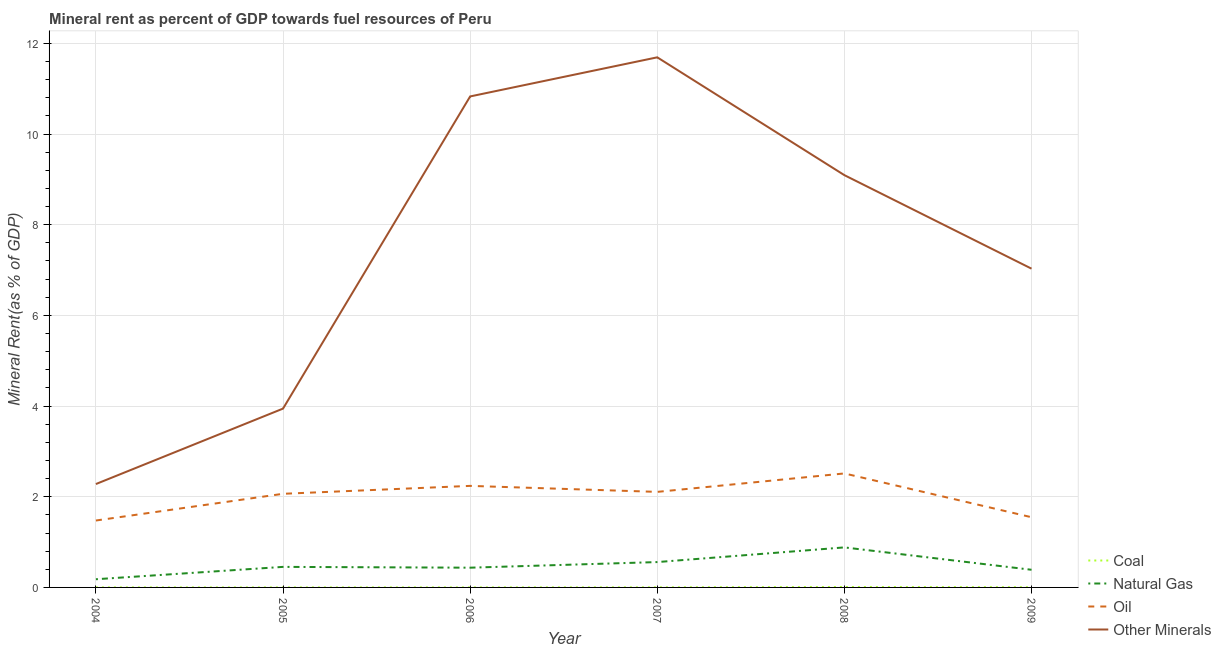Is the number of lines equal to the number of legend labels?
Offer a very short reply. Yes. What is the coal rent in 2007?
Make the answer very short. 0. Across all years, what is the maximum coal rent?
Your answer should be very brief. 0.01. Across all years, what is the minimum coal rent?
Offer a terse response. 0. What is the total  rent of other minerals in the graph?
Keep it short and to the point. 44.87. What is the difference between the natural gas rent in 2006 and that in 2007?
Your answer should be very brief. -0.12. What is the difference between the natural gas rent in 2004 and the coal rent in 2005?
Your answer should be very brief. 0.18. What is the average coal rent per year?
Your answer should be very brief. 0. In the year 2009, what is the difference between the natural gas rent and  rent of other minerals?
Provide a short and direct response. -6.64. What is the ratio of the  rent of other minerals in 2004 to that in 2006?
Keep it short and to the point. 0.21. Is the natural gas rent in 2005 less than that in 2007?
Ensure brevity in your answer.  Yes. Is the difference between the  rent of other minerals in 2007 and 2009 greater than the difference between the coal rent in 2007 and 2009?
Provide a short and direct response. Yes. What is the difference between the highest and the second highest natural gas rent?
Offer a terse response. 0.32. What is the difference between the highest and the lowest coal rent?
Your response must be concise. 0.01. Is it the case that in every year, the sum of the coal rent and natural gas rent is greater than the oil rent?
Your answer should be very brief. No. Does the  rent of other minerals monotonically increase over the years?
Offer a very short reply. No. Is the natural gas rent strictly greater than the coal rent over the years?
Offer a terse response. Yes. Is the natural gas rent strictly less than the coal rent over the years?
Provide a short and direct response. No. How many lines are there?
Ensure brevity in your answer.  4. Does the graph contain any zero values?
Your answer should be very brief. No. Does the graph contain grids?
Ensure brevity in your answer.  Yes. How many legend labels are there?
Provide a short and direct response. 4. How are the legend labels stacked?
Keep it short and to the point. Vertical. What is the title of the graph?
Offer a terse response. Mineral rent as percent of GDP towards fuel resources of Peru. What is the label or title of the Y-axis?
Offer a very short reply. Mineral Rent(as % of GDP). What is the Mineral Rent(as % of GDP) of Coal in 2004?
Ensure brevity in your answer.  0. What is the Mineral Rent(as % of GDP) of Natural Gas in 2004?
Offer a very short reply. 0.18. What is the Mineral Rent(as % of GDP) of Oil in 2004?
Keep it short and to the point. 1.48. What is the Mineral Rent(as % of GDP) in Other Minerals in 2004?
Give a very brief answer. 2.28. What is the Mineral Rent(as % of GDP) in Coal in 2005?
Your answer should be very brief. 0. What is the Mineral Rent(as % of GDP) of Natural Gas in 2005?
Make the answer very short. 0.45. What is the Mineral Rent(as % of GDP) in Oil in 2005?
Your answer should be very brief. 2.07. What is the Mineral Rent(as % of GDP) of Other Minerals in 2005?
Ensure brevity in your answer.  3.94. What is the Mineral Rent(as % of GDP) in Coal in 2006?
Offer a terse response. 0. What is the Mineral Rent(as % of GDP) of Natural Gas in 2006?
Your answer should be compact. 0.44. What is the Mineral Rent(as % of GDP) of Oil in 2006?
Your answer should be very brief. 2.24. What is the Mineral Rent(as % of GDP) in Other Minerals in 2006?
Your answer should be very brief. 10.83. What is the Mineral Rent(as % of GDP) of Coal in 2007?
Keep it short and to the point. 0. What is the Mineral Rent(as % of GDP) of Natural Gas in 2007?
Your answer should be compact. 0.56. What is the Mineral Rent(as % of GDP) in Oil in 2007?
Your response must be concise. 2.11. What is the Mineral Rent(as % of GDP) in Other Minerals in 2007?
Your answer should be very brief. 11.69. What is the Mineral Rent(as % of GDP) in Coal in 2008?
Give a very brief answer. 0.01. What is the Mineral Rent(as % of GDP) of Natural Gas in 2008?
Your answer should be compact. 0.88. What is the Mineral Rent(as % of GDP) of Oil in 2008?
Keep it short and to the point. 2.51. What is the Mineral Rent(as % of GDP) in Other Minerals in 2008?
Ensure brevity in your answer.  9.09. What is the Mineral Rent(as % of GDP) of Coal in 2009?
Provide a short and direct response. 0. What is the Mineral Rent(as % of GDP) in Natural Gas in 2009?
Your answer should be compact. 0.39. What is the Mineral Rent(as % of GDP) of Oil in 2009?
Offer a terse response. 1.55. What is the Mineral Rent(as % of GDP) of Other Minerals in 2009?
Keep it short and to the point. 7.03. Across all years, what is the maximum Mineral Rent(as % of GDP) in Coal?
Your answer should be compact. 0.01. Across all years, what is the maximum Mineral Rent(as % of GDP) of Natural Gas?
Offer a very short reply. 0.88. Across all years, what is the maximum Mineral Rent(as % of GDP) in Oil?
Provide a succinct answer. 2.51. Across all years, what is the maximum Mineral Rent(as % of GDP) of Other Minerals?
Offer a terse response. 11.69. Across all years, what is the minimum Mineral Rent(as % of GDP) in Coal?
Keep it short and to the point. 0. Across all years, what is the minimum Mineral Rent(as % of GDP) in Natural Gas?
Ensure brevity in your answer.  0.18. Across all years, what is the minimum Mineral Rent(as % of GDP) in Oil?
Offer a terse response. 1.48. Across all years, what is the minimum Mineral Rent(as % of GDP) in Other Minerals?
Make the answer very short. 2.28. What is the total Mineral Rent(as % of GDP) of Coal in the graph?
Ensure brevity in your answer.  0.02. What is the total Mineral Rent(as % of GDP) of Natural Gas in the graph?
Offer a very short reply. 2.9. What is the total Mineral Rent(as % of GDP) in Oil in the graph?
Offer a very short reply. 11.95. What is the total Mineral Rent(as % of GDP) in Other Minerals in the graph?
Offer a terse response. 44.87. What is the difference between the Mineral Rent(as % of GDP) in Coal in 2004 and that in 2005?
Offer a terse response. 0. What is the difference between the Mineral Rent(as % of GDP) of Natural Gas in 2004 and that in 2005?
Ensure brevity in your answer.  -0.27. What is the difference between the Mineral Rent(as % of GDP) of Oil in 2004 and that in 2005?
Your answer should be very brief. -0.59. What is the difference between the Mineral Rent(as % of GDP) in Other Minerals in 2004 and that in 2005?
Ensure brevity in your answer.  -1.66. What is the difference between the Mineral Rent(as % of GDP) of Coal in 2004 and that in 2006?
Your response must be concise. -0. What is the difference between the Mineral Rent(as % of GDP) in Natural Gas in 2004 and that in 2006?
Keep it short and to the point. -0.25. What is the difference between the Mineral Rent(as % of GDP) of Oil in 2004 and that in 2006?
Ensure brevity in your answer.  -0.76. What is the difference between the Mineral Rent(as % of GDP) in Other Minerals in 2004 and that in 2006?
Your answer should be very brief. -8.55. What is the difference between the Mineral Rent(as % of GDP) of Coal in 2004 and that in 2007?
Offer a very short reply. -0. What is the difference between the Mineral Rent(as % of GDP) in Natural Gas in 2004 and that in 2007?
Your answer should be compact. -0.38. What is the difference between the Mineral Rent(as % of GDP) of Oil in 2004 and that in 2007?
Offer a very short reply. -0.63. What is the difference between the Mineral Rent(as % of GDP) of Other Minerals in 2004 and that in 2007?
Provide a short and direct response. -9.41. What is the difference between the Mineral Rent(as % of GDP) of Coal in 2004 and that in 2008?
Ensure brevity in your answer.  -0.01. What is the difference between the Mineral Rent(as % of GDP) in Natural Gas in 2004 and that in 2008?
Ensure brevity in your answer.  -0.7. What is the difference between the Mineral Rent(as % of GDP) of Oil in 2004 and that in 2008?
Make the answer very short. -1.04. What is the difference between the Mineral Rent(as % of GDP) in Other Minerals in 2004 and that in 2008?
Your answer should be compact. -6.81. What is the difference between the Mineral Rent(as % of GDP) in Coal in 2004 and that in 2009?
Keep it short and to the point. -0. What is the difference between the Mineral Rent(as % of GDP) of Natural Gas in 2004 and that in 2009?
Provide a succinct answer. -0.21. What is the difference between the Mineral Rent(as % of GDP) of Oil in 2004 and that in 2009?
Give a very brief answer. -0.07. What is the difference between the Mineral Rent(as % of GDP) in Other Minerals in 2004 and that in 2009?
Make the answer very short. -4.75. What is the difference between the Mineral Rent(as % of GDP) in Coal in 2005 and that in 2006?
Provide a short and direct response. -0. What is the difference between the Mineral Rent(as % of GDP) in Natural Gas in 2005 and that in 2006?
Your answer should be compact. 0.02. What is the difference between the Mineral Rent(as % of GDP) of Oil in 2005 and that in 2006?
Your answer should be very brief. -0.17. What is the difference between the Mineral Rent(as % of GDP) in Other Minerals in 2005 and that in 2006?
Offer a terse response. -6.89. What is the difference between the Mineral Rent(as % of GDP) of Coal in 2005 and that in 2007?
Keep it short and to the point. -0. What is the difference between the Mineral Rent(as % of GDP) of Natural Gas in 2005 and that in 2007?
Ensure brevity in your answer.  -0.11. What is the difference between the Mineral Rent(as % of GDP) in Oil in 2005 and that in 2007?
Give a very brief answer. -0.04. What is the difference between the Mineral Rent(as % of GDP) in Other Minerals in 2005 and that in 2007?
Offer a terse response. -7.75. What is the difference between the Mineral Rent(as % of GDP) in Coal in 2005 and that in 2008?
Your response must be concise. -0.01. What is the difference between the Mineral Rent(as % of GDP) in Natural Gas in 2005 and that in 2008?
Provide a succinct answer. -0.43. What is the difference between the Mineral Rent(as % of GDP) of Oil in 2005 and that in 2008?
Give a very brief answer. -0.45. What is the difference between the Mineral Rent(as % of GDP) in Other Minerals in 2005 and that in 2008?
Give a very brief answer. -5.15. What is the difference between the Mineral Rent(as % of GDP) in Coal in 2005 and that in 2009?
Keep it short and to the point. -0. What is the difference between the Mineral Rent(as % of GDP) in Natural Gas in 2005 and that in 2009?
Your response must be concise. 0.06. What is the difference between the Mineral Rent(as % of GDP) in Oil in 2005 and that in 2009?
Offer a very short reply. 0.52. What is the difference between the Mineral Rent(as % of GDP) of Other Minerals in 2005 and that in 2009?
Provide a succinct answer. -3.09. What is the difference between the Mineral Rent(as % of GDP) in Coal in 2006 and that in 2007?
Your response must be concise. -0. What is the difference between the Mineral Rent(as % of GDP) of Natural Gas in 2006 and that in 2007?
Ensure brevity in your answer.  -0.12. What is the difference between the Mineral Rent(as % of GDP) in Oil in 2006 and that in 2007?
Make the answer very short. 0.13. What is the difference between the Mineral Rent(as % of GDP) in Other Minerals in 2006 and that in 2007?
Your answer should be compact. -0.86. What is the difference between the Mineral Rent(as % of GDP) in Coal in 2006 and that in 2008?
Your response must be concise. -0.01. What is the difference between the Mineral Rent(as % of GDP) of Natural Gas in 2006 and that in 2008?
Make the answer very short. -0.45. What is the difference between the Mineral Rent(as % of GDP) in Oil in 2006 and that in 2008?
Keep it short and to the point. -0.27. What is the difference between the Mineral Rent(as % of GDP) in Other Minerals in 2006 and that in 2008?
Offer a very short reply. 1.74. What is the difference between the Mineral Rent(as % of GDP) of Coal in 2006 and that in 2009?
Your answer should be very brief. -0. What is the difference between the Mineral Rent(as % of GDP) of Natural Gas in 2006 and that in 2009?
Give a very brief answer. 0.05. What is the difference between the Mineral Rent(as % of GDP) of Oil in 2006 and that in 2009?
Your answer should be very brief. 0.69. What is the difference between the Mineral Rent(as % of GDP) in Other Minerals in 2006 and that in 2009?
Offer a very short reply. 3.8. What is the difference between the Mineral Rent(as % of GDP) in Coal in 2007 and that in 2008?
Make the answer very short. -0.01. What is the difference between the Mineral Rent(as % of GDP) of Natural Gas in 2007 and that in 2008?
Provide a short and direct response. -0.32. What is the difference between the Mineral Rent(as % of GDP) in Oil in 2007 and that in 2008?
Keep it short and to the point. -0.41. What is the difference between the Mineral Rent(as % of GDP) of Other Minerals in 2007 and that in 2008?
Provide a short and direct response. 2.6. What is the difference between the Mineral Rent(as % of GDP) of Coal in 2007 and that in 2009?
Your answer should be very brief. -0. What is the difference between the Mineral Rent(as % of GDP) of Natural Gas in 2007 and that in 2009?
Provide a short and direct response. 0.17. What is the difference between the Mineral Rent(as % of GDP) in Oil in 2007 and that in 2009?
Give a very brief answer. 0.56. What is the difference between the Mineral Rent(as % of GDP) of Other Minerals in 2007 and that in 2009?
Provide a short and direct response. 4.66. What is the difference between the Mineral Rent(as % of GDP) in Coal in 2008 and that in 2009?
Provide a short and direct response. 0. What is the difference between the Mineral Rent(as % of GDP) of Natural Gas in 2008 and that in 2009?
Your answer should be compact. 0.49. What is the difference between the Mineral Rent(as % of GDP) of Oil in 2008 and that in 2009?
Offer a very short reply. 0.97. What is the difference between the Mineral Rent(as % of GDP) in Other Minerals in 2008 and that in 2009?
Provide a short and direct response. 2.06. What is the difference between the Mineral Rent(as % of GDP) in Coal in 2004 and the Mineral Rent(as % of GDP) in Natural Gas in 2005?
Offer a very short reply. -0.45. What is the difference between the Mineral Rent(as % of GDP) of Coal in 2004 and the Mineral Rent(as % of GDP) of Oil in 2005?
Keep it short and to the point. -2.06. What is the difference between the Mineral Rent(as % of GDP) in Coal in 2004 and the Mineral Rent(as % of GDP) in Other Minerals in 2005?
Keep it short and to the point. -3.94. What is the difference between the Mineral Rent(as % of GDP) of Natural Gas in 2004 and the Mineral Rent(as % of GDP) of Oil in 2005?
Offer a terse response. -1.88. What is the difference between the Mineral Rent(as % of GDP) in Natural Gas in 2004 and the Mineral Rent(as % of GDP) in Other Minerals in 2005?
Your response must be concise. -3.76. What is the difference between the Mineral Rent(as % of GDP) of Oil in 2004 and the Mineral Rent(as % of GDP) of Other Minerals in 2005?
Your response must be concise. -2.47. What is the difference between the Mineral Rent(as % of GDP) of Coal in 2004 and the Mineral Rent(as % of GDP) of Natural Gas in 2006?
Keep it short and to the point. -0.44. What is the difference between the Mineral Rent(as % of GDP) in Coal in 2004 and the Mineral Rent(as % of GDP) in Oil in 2006?
Ensure brevity in your answer.  -2.24. What is the difference between the Mineral Rent(as % of GDP) in Coal in 2004 and the Mineral Rent(as % of GDP) in Other Minerals in 2006?
Your response must be concise. -10.83. What is the difference between the Mineral Rent(as % of GDP) in Natural Gas in 2004 and the Mineral Rent(as % of GDP) in Oil in 2006?
Your response must be concise. -2.06. What is the difference between the Mineral Rent(as % of GDP) in Natural Gas in 2004 and the Mineral Rent(as % of GDP) in Other Minerals in 2006?
Offer a terse response. -10.65. What is the difference between the Mineral Rent(as % of GDP) in Oil in 2004 and the Mineral Rent(as % of GDP) in Other Minerals in 2006?
Your answer should be very brief. -9.35. What is the difference between the Mineral Rent(as % of GDP) in Coal in 2004 and the Mineral Rent(as % of GDP) in Natural Gas in 2007?
Make the answer very short. -0.56. What is the difference between the Mineral Rent(as % of GDP) of Coal in 2004 and the Mineral Rent(as % of GDP) of Oil in 2007?
Offer a terse response. -2.11. What is the difference between the Mineral Rent(as % of GDP) in Coal in 2004 and the Mineral Rent(as % of GDP) in Other Minerals in 2007?
Give a very brief answer. -11.69. What is the difference between the Mineral Rent(as % of GDP) of Natural Gas in 2004 and the Mineral Rent(as % of GDP) of Oil in 2007?
Your answer should be compact. -1.93. What is the difference between the Mineral Rent(as % of GDP) in Natural Gas in 2004 and the Mineral Rent(as % of GDP) in Other Minerals in 2007?
Your answer should be very brief. -11.51. What is the difference between the Mineral Rent(as % of GDP) of Oil in 2004 and the Mineral Rent(as % of GDP) of Other Minerals in 2007?
Provide a succinct answer. -10.22. What is the difference between the Mineral Rent(as % of GDP) of Coal in 2004 and the Mineral Rent(as % of GDP) of Natural Gas in 2008?
Keep it short and to the point. -0.88. What is the difference between the Mineral Rent(as % of GDP) in Coal in 2004 and the Mineral Rent(as % of GDP) in Oil in 2008?
Offer a very short reply. -2.51. What is the difference between the Mineral Rent(as % of GDP) in Coal in 2004 and the Mineral Rent(as % of GDP) in Other Minerals in 2008?
Provide a short and direct response. -9.09. What is the difference between the Mineral Rent(as % of GDP) in Natural Gas in 2004 and the Mineral Rent(as % of GDP) in Oil in 2008?
Offer a very short reply. -2.33. What is the difference between the Mineral Rent(as % of GDP) of Natural Gas in 2004 and the Mineral Rent(as % of GDP) of Other Minerals in 2008?
Provide a succinct answer. -8.91. What is the difference between the Mineral Rent(as % of GDP) in Oil in 2004 and the Mineral Rent(as % of GDP) in Other Minerals in 2008?
Give a very brief answer. -7.62. What is the difference between the Mineral Rent(as % of GDP) in Coal in 2004 and the Mineral Rent(as % of GDP) in Natural Gas in 2009?
Ensure brevity in your answer.  -0.39. What is the difference between the Mineral Rent(as % of GDP) of Coal in 2004 and the Mineral Rent(as % of GDP) of Oil in 2009?
Provide a succinct answer. -1.55. What is the difference between the Mineral Rent(as % of GDP) of Coal in 2004 and the Mineral Rent(as % of GDP) of Other Minerals in 2009?
Provide a short and direct response. -7.03. What is the difference between the Mineral Rent(as % of GDP) of Natural Gas in 2004 and the Mineral Rent(as % of GDP) of Oil in 2009?
Your response must be concise. -1.37. What is the difference between the Mineral Rent(as % of GDP) in Natural Gas in 2004 and the Mineral Rent(as % of GDP) in Other Minerals in 2009?
Provide a succinct answer. -6.85. What is the difference between the Mineral Rent(as % of GDP) of Oil in 2004 and the Mineral Rent(as % of GDP) of Other Minerals in 2009?
Offer a very short reply. -5.56. What is the difference between the Mineral Rent(as % of GDP) in Coal in 2005 and the Mineral Rent(as % of GDP) in Natural Gas in 2006?
Give a very brief answer. -0.44. What is the difference between the Mineral Rent(as % of GDP) in Coal in 2005 and the Mineral Rent(as % of GDP) in Oil in 2006?
Your response must be concise. -2.24. What is the difference between the Mineral Rent(as % of GDP) of Coal in 2005 and the Mineral Rent(as % of GDP) of Other Minerals in 2006?
Ensure brevity in your answer.  -10.83. What is the difference between the Mineral Rent(as % of GDP) in Natural Gas in 2005 and the Mineral Rent(as % of GDP) in Oil in 2006?
Give a very brief answer. -1.79. What is the difference between the Mineral Rent(as % of GDP) in Natural Gas in 2005 and the Mineral Rent(as % of GDP) in Other Minerals in 2006?
Provide a succinct answer. -10.38. What is the difference between the Mineral Rent(as % of GDP) of Oil in 2005 and the Mineral Rent(as % of GDP) of Other Minerals in 2006?
Give a very brief answer. -8.76. What is the difference between the Mineral Rent(as % of GDP) in Coal in 2005 and the Mineral Rent(as % of GDP) in Natural Gas in 2007?
Provide a succinct answer. -0.56. What is the difference between the Mineral Rent(as % of GDP) of Coal in 2005 and the Mineral Rent(as % of GDP) of Oil in 2007?
Offer a terse response. -2.11. What is the difference between the Mineral Rent(as % of GDP) of Coal in 2005 and the Mineral Rent(as % of GDP) of Other Minerals in 2007?
Provide a short and direct response. -11.69. What is the difference between the Mineral Rent(as % of GDP) in Natural Gas in 2005 and the Mineral Rent(as % of GDP) in Oil in 2007?
Ensure brevity in your answer.  -1.65. What is the difference between the Mineral Rent(as % of GDP) in Natural Gas in 2005 and the Mineral Rent(as % of GDP) in Other Minerals in 2007?
Your answer should be compact. -11.24. What is the difference between the Mineral Rent(as % of GDP) of Oil in 2005 and the Mineral Rent(as % of GDP) of Other Minerals in 2007?
Your answer should be very brief. -9.63. What is the difference between the Mineral Rent(as % of GDP) of Coal in 2005 and the Mineral Rent(as % of GDP) of Natural Gas in 2008?
Provide a short and direct response. -0.88. What is the difference between the Mineral Rent(as % of GDP) of Coal in 2005 and the Mineral Rent(as % of GDP) of Oil in 2008?
Offer a terse response. -2.51. What is the difference between the Mineral Rent(as % of GDP) of Coal in 2005 and the Mineral Rent(as % of GDP) of Other Minerals in 2008?
Your answer should be compact. -9.09. What is the difference between the Mineral Rent(as % of GDP) in Natural Gas in 2005 and the Mineral Rent(as % of GDP) in Oil in 2008?
Offer a very short reply. -2.06. What is the difference between the Mineral Rent(as % of GDP) of Natural Gas in 2005 and the Mineral Rent(as % of GDP) of Other Minerals in 2008?
Offer a terse response. -8.64. What is the difference between the Mineral Rent(as % of GDP) in Oil in 2005 and the Mineral Rent(as % of GDP) in Other Minerals in 2008?
Keep it short and to the point. -7.03. What is the difference between the Mineral Rent(as % of GDP) in Coal in 2005 and the Mineral Rent(as % of GDP) in Natural Gas in 2009?
Ensure brevity in your answer.  -0.39. What is the difference between the Mineral Rent(as % of GDP) of Coal in 2005 and the Mineral Rent(as % of GDP) of Oil in 2009?
Your answer should be very brief. -1.55. What is the difference between the Mineral Rent(as % of GDP) of Coal in 2005 and the Mineral Rent(as % of GDP) of Other Minerals in 2009?
Provide a succinct answer. -7.03. What is the difference between the Mineral Rent(as % of GDP) of Natural Gas in 2005 and the Mineral Rent(as % of GDP) of Oil in 2009?
Your response must be concise. -1.1. What is the difference between the Mineral Rent(as % of GDP) in Natural Gas in 2005 and the Mineral Rent(as % of GDP) in Other Minerals in 2009?
Offer a very short reply. -6.58. What is the difference between the Mineral Rent(as % of GDP) in Oil in 2005 and the Mineral Rent(as % of GDP) in Other Minerals in 2009?
Your answer should be very brief. -4.97. What is the difference between the Mineral Rent(as % of GDP) in Coal in 2006 and the Mineral Rent(as % of GDP) in Natural Gas in 2007?
Ensure brevity in your answer.  -0.56. What is the difference between the Mineral Rent(as % of GDP) of Coal in 2006 and the Mineral Rent(as % of GDP) of Oil in 2007?
Give a very brief answer. -2.11. What is the difference between the Mineral Rent(as % of GDP) in Coal in 2006 and the Mineral Rent(as % of GDP) in Other Minerals in 2007?
Your response must be concise. -11.69. What is the difference between the Mineral Rent(as % of GDP) in Natural Gas in 2006 and the Mineral Rent(as % of GDP) in Oil in 2007?
Make the answer very short. -1.67. What is the difference between the Mineral Rent(as % of GDP) of Natural Gas in 2006 and the Mineral Rent(as % of GDP) of Other Minerals in 2007?
Provide a short and direct response. -11.26. What is the difference between the Mineral Rent(as % of GDP) of Oil in 2006 and the Mineral Rent(as % of GDP) of Other Minerals in 2007?
Offer a terse response. -9.45. What is the difference between the Mineral Rent(as % of GDP) of Coal in 2006 and the Mineral Rent(as % of GDP) of Natural Gas in 2008?
Your answer should be compact. -0.88. What is the difference between the Mineral Rent(as % of GDP) in Coal in 2006 and the Mineral Rent(as % of GDP) in Oil in 2008?
Make the answer very short. -2.51. What is the difference between the Mineral Rent(as % of GDP) of Coal in 2006 and the Mineral Rent(as % of GDP) of Other Minerals in 2008?
Your response must be concise. -9.09. What is the difference between the Mineral Rent(as % of GDP) in Natural Gas in 2006 and the Mineral Rent(as % of GDP) in Oil in 2008?
Ensure brevity in your answer.  -2.08. What is the difference between the Mineral Rent(as % of GDP) of Natural Gas in 2006 and the Mineral Rent(as % of GDP) of Other Minerals in 2008?
Your answer should be compact. -8.66. What is the difference between the Mineral Rent(as % of GDP) of Oil in 2006 and the Mineral Rent(as % of GDP) of Other Minerals in 2008?
Your response must be concise. -6.85. What is the difference between the Mineral Rent(as % of GDP) in Coal in 2006 and the Mineral Rent(as % of GDP) in Natural Gas in 2009?
Your answer should be compact. -0.39. What is the difference between the Mineral Rent(as % of GDP) of Coal in 2006 and the Mineral Rent(as % of GDP) of Oil in 2009?
Your answer should be compact. -1.55. What is the difference between the Mineral Rent(as % of GDP) of Coal in 2006 and the Mineral Rent(as % of GDP) of Other Minerals in 2009?
Ensure brevity in your answer.  -7.03. What is the difference between the Mineral Rent(as % of GDP) of Natural Gas in 2006 and the Mineral Rent(as % of GDP) of Oil in 2009?
Your answer should be compact. -1.11. What is the difference between the Mineral Rent(as % of GDP) in Natural Gas in 2006 and the Mineral Rent(as % of GDP) in Other Minerals in 2009?
Make the answer very short. -6.6. What is the difference between the Mineral Rent(as % of GDP) of Oil in 2006 and the Mineral Rent(as % of GDP) of Other Minerals in 2009?
Offer a terse response. -4.79. What is the difference between the Mineral Rent(as % of GDP) in Coal in 2007 and the Mineral Rent(as % of GDP) in Natural Gas in 2008?
Offer a very short reply. -0.88. What is the difference between the Mineral Rent(as % of GDP) of Coal in 2007 and the Mineral Rent(as % of GDP) of Oil in 2008?
Your answer should be very brief. -2.51. What is the difference between the Mineral Rent(as % of GDP) in Coal in 2007 and the Mineral Rent(as % of GDP) in Other Minerals in 2008?
Your answer should be very brief. -9.09. What is the difference between the Mineral Rent(as % of GDP) of Natural Gas in 2007 and the Mineral Rent(as % of GDP) of Oil in 2008?
Your response must be concise. -1.96. What is the difference between the Mineral Rent(as % of GDP) of Natural Gas in 2007 and the Mineral Rent(as % of GDP) of Other Minerals in 2008?
Make the answer very short. -8.53. What is the difference between the Mineral Rent(as % of GDP) in Oil in 2007 and the Mineral Rent(as % of GDP) in Other Minerals in 2008?
Provide a short and direct response. -6.99. What is the difference between the Mineral Rent(as % of GDP) in Coal in 2007 and the Mineral Rent(as % of GDP) in Natural Gas in 2009?
Provide a short and direct response. -0.39. What is the difference between the Mineral Rent(as % of GDP) of Coal in 2007 and the Mineral Rent(as % of GDP) of Oil in 2009?
Your response must be concise. -1.55. What is the difference between the Mineral Rent(as % of GDP) in Coal in 2007 and the Mineral Rent(as % of GDP) in Other Minerals in 2009?
Provide a succinct answer. -7.03. What is the difference between the Mineral Rent(as % of GDP) in Natural Gas in 2007 and the Mineral Rent(as % of GDP) in Oil in 2009?
Offer a terse response. -0.99. What is the difference between the Mineral Rent(as % of GDP) in Natural Gas in 2007 and the Mineral Rent(as % of GDP) in Other Minerals in 2009?
Make the answer very short. -6.47. What is the difference between the Mineral Rent(as % of GDP) of Oil in 2007 and the Mineral Rent(as % of GDP) of Other Minerals in 2009?
Make the answer very short. -4.92. What is the difference between the Mineral Rent(as % of GDP) in Coal in 2008 and the Mineral Rent(as % of GDP) in Natural Gas in 2009?
Provide a short and direct response. -0.38. What is the difference between the Mineral Rent(as % of GDP) in Coal in 2008 and the Mineral Rent(as % of GDP) in Oil in 2009?
Your answer should be very brief. -1.54. What is the difference between the Mineral Rent(as % of GDP) in Coal in 2008 and the Mineral Rent(as % of GDP) in Other Minerals in 2009?
Your answer should be compact. -7.02. What is the difference between the Mineral Rent(as % of GDP) in Natural Gas in 2008 and the Mineral Rent(as % of GDP) in Oil in 2009?
Offer a very short reply. -0.67. What is the difference between the Mineral Rent(as % of GDP) of Natural Gas in 2008 and the Mineral Rent(as % of GDP) of Other Minerals in 2009?
Provide a short and direct response. -6.15. What is the difference between the Mineral Rent(as % of GDP) of Oil in 2008 and the Mineral Rent(as % of GDP) of Other Minerals in 2009?
Offer a terse response. -4.52. What is the average Mineral Rent(as % of GDP) in Coal per year?
Your answer should be compact. 0. What is the average Mineral Rent(as % of GDP) in Natural Gas per year?
Provide a short and direct response. 0.48. What is the average Mineral Rent(as % of GDP) in Oil per year?
Give a very brief answer. 1.99. What is the average Mineral Rent(as % of GDP) in Other Minerals per year?
Provide a succinct answer. 7.48. In the year 2004, what is the difference between the Mineral Rent(as % of GDP) in Coal and Mineral Rent(as % of GDP) in Natural Gas?
Offer a terse response. -0.18. In the year 2004, what is the difference between the Mineral Rent(as % of GDP) in Coal and Mineral Rent(as % of GDP) in Oil?
Ensure brevity in your answer.  -1.48. In the year 2004, what is the difference between the Mineral Rent(as % of GDP) in Coal and Mineral Rent(as % of GDP) in Other Minerals?
Provide a succinct answer. -2.28. In the year 2004, what is the difference between the Mineral Rent(as % of GDP) of Natural Gas and Mineral Rent(as % of GDP) of Oil?
Your answer should be very brief. -1.3. In the year 2004, what is the difference between the Mineral Rent(as % of GDP) in Natural Gas and Mineral Rent(as % of GDP) in Other Minerals?
Make the answer very short. -2.1. In the year 2004, what is the difference between the Mineral Rent(as % of GDP) in Oil and Mineral Rent(as % of GDP) in Other Minerals?
Your answer should be compact. -0.8. In the year 2005, what is the difference between the Mineral Rent(as % of GDP) in Coal and Mineral Rent(as % of GDP) in Natural Gas?
Keep it short and to the point. -0.45. In the year 2005, what is the difference between the Mineral Rent(as % of GDP) in Coal and Mineral Rent(as % of GDP) in Oil?
Provide a succinct answer. -2.07. In the year 2005, what is the difference between the Mineral Rent(as % of GDP) in Coal and Mineral Rent(as % of GDP) in Other Minerals?
Make the answer very short. -3.94. In the year 2005, what is the difference between the Mineral Rent(as % of GDP) in Natural Gas and Mineral Rent(as % of GDP) in Oil?
Your answer should be compact. -1.61. In the year 2005, what is the difference between the Mineral Rent(as % of GDP) in Natural Gas and Mineral Rent(as % of GDP) in Other Minerals?
Provide a succinct answer. -3.49. In the year 2005, what is the difference between the Mineral Rent(as % of GDP) of Oil and Mineral Rent(as % of GDP) of Other Minerals?
Keep it short and to the point. -1.88. In the year 2006, what is the difference between the Mineral Rent(as % of GDP) in Coal and Mineral Rent(as % of GDP) in Natural Gas?
Offer a terse response. -0.43. In the year 2006, what is the difference between the Mineral Rent(as % of GDP) in Coal and Mineral Rent(as % of GDP) in Oil?
Offer a terse response. -2.24. In the year 2006, what is the difference between the Mineral Rent(as % of GDP) in Coal and Mineral Rent(as % of GDP) in Other Minerals?
Offer a very short reply. -10.83. In the year 2006, what is the difference between the Mineral Rent(as % of GDP) of Natural Gas and Mineral Rent(as % of GDP) of Oil?
Your answer should be very brief. -1.8. In the year 2006, what is the difference between the Mineral Rent(as % of GDP) in Natural Gas and Mineral Rent(as % of GDP) in Other Minerals?
Ensure brevity in your answer.  -10.39. In the year 2006, what is the difference between the Mineral Rent(as % of GDP) in Oil and Mineral Rent(as % of GDP) in Other Minerals?
Give a very brief answer. -8.59. In the year 2007, what is the difference between the Mineral Rent(as % of GDP) of Coal and Mineral Rent(as % of GDP) of Natural Gas?
Keep it short and to the point. -0.56. In the year 2007, what is the difference between the Mineral Rent(as % of GDP) of Coal and Mineral Rent(as % of GDP) of Oil?
Your answer should be compact. -2.11. In the year 2007, what is the difference between the Mineral Rent(as % of GDP) of Coal and Mineral Rent(as % of GDP) of Other Minerals?
Keep it short and to the point. -11.69. In the year 2007, what is the difference between the Mineral Rent(as % of GDP) in Natural Gas and Mineral Rent(as % of GDP) in Oil?
Your response must be concise. -1.55. In the year 2007, what is the difference between the Mineral Rent(as % of GDP) of Natural Gas and Mineral Rent(as % of GDP) of Other Minerals?
Offer a very short reply. -11.13. In the year 2007, what is the difference between the Mineral Rent(as % of GDP) in Oil and Mineral Rent(as % of GDP) in Other Minerals?
Offer a very short reply. -9.58. In the year 2008, what is the difference between the Mineral Rent(as % of GDP) of Coal and Mineral Rent(as % of GDP) of Natural Gas?
Provide a succinct answer. -0.87. In the year 2008, what is the difference between the Mineral Rent(as % of GDP) of Coal and Mineral Rent(as % of GDP) of Oil?
Provide a short and direct response. -2.51. In the year 2008, what is the difference between the Mineral Rent(as % of GDP) in Coal and Mineral Rent(as % of GDP) in Other Minerals?
Offer a terse response. -9.08. In the year 2008, what is the difference between the Mineral Rent(as % of GDP) in Natural Gas and Mineral Rent(as % of GDP) in Oil?
Provide a short and direct response. -1.63. In the year 2008, what is the difference between the Mineral Rent(as % of GDP) of Natural Gas and Mineral Rent(as % of GDP) of Other Minerals?
Provide a short and direct response. -8.21. In the year 2008, what is the difference between the Mineral Rent(as % of GDP) of Oil and Mineral Rent(as % of GDP) of Other Minerals?
Your answer should be very brief. -6.58. In the year 2009, what is the difference between the Mineral Rent(as % of GDP) in Coal and Mineral Rent(as % of GDP) in Natural Gas?
Provide a short and direct response. -0.39. In the year 2009, what is the difference between the Mineral Rent(as % of GDP) in Coal and Mineral Rent(as % of GDP) in Oil?
Provide a succinct answer. -1.54. In the year 2009, what is the difference between the Mineral Rent(as % of GDP) of Coal and Mineral Rent(as % of GDP) of Other Minerals?
Provide a succinct answer. -7.03. In the year 2009, what is the difference between the Mineral Rent(as % of GDP) of Natural Gas and Mineral Rent(as % of GDP) of Oil?
Your answer should be compact. -1.16. In the year 2009, what is the difference between the Mineral Rent(as % of GDP) of Natural Gas and Mineral Rent(as % of GDP) of Other Minerals?
Your answer should be compact. -6.64. In the year 2009, what is the difference between the Mineral Rent(as % of GDP) of Oil and Mineral Rent(as % of GDP) of Other Minerals?
Provide a succinct answer. -5.48. What is the ratio of the Mineral Rent(as % of GDP) of Coal in 2004 to that in 2005?
Offer a terse response. 3.1. What is the ratio of the Mineral Rent(as % of GDP) in Natural Gas in 2004 to that in 2005?
Provide a short and direct response. 0.4. What is the ratio of the Mineral Rent(as % of GDP) of Oil in 2004 to that in 2005?
Provide a succinct answer. 0.71. What is the ratio of the Mineral Rent(as % of GDP) in Other Minerals in 2004 to that in 2005?
Offer a terse response. 0.58. What is the ratio of the Mineral Rent(as % of GDP) of Coal in 2004 to that in 2006?
Provide a succinct answer. 0.79. What is the ratio of the Mineral Rent(as % of GDP) of Natural Gas in 2004 to that in 2006?
Your answer should be compact. 0.41. What is the ratio of the Mineral Rent(as % of GDP) in Oil in 2004 to that in 2006?
Give a very brief answer. 0.66. What is the ratio of the Mineral Rent(as % of GDP) in Other Minerals in 2004 to that in 2006?
Offer a terse response. 0.21. What is the ratio of the Mineral Rent(as % of GDP) in Coal in 2004 to that in 2007?
Your answer should be very brief. 0.24. What is the ratio of the Mineral Rent(as % of GDP) of Natural Gas in 2004 to that in 2007?
Your answer should be compact. 0.32. What is the ratio of the Mineral Rent(as % of GDP) in Oil in 2004 to that in 2007?
Your response must be concise. 0.7. What is the ratio of the Mineral Rent(as % of GDP) in Other Minerals in 2004 to that in 2007?
Your answer should be very brief. 0.2. What is the ratio of the Mineral Rent(as % of GDP) in Coal in 2004 to that in 2008?
Give a very brief answer. 0.05. What is the ratio of the Mineral Rent(as % of GDP) of Natural Gas in 2004 to that in 2008?
Provide a short and direct response. 0.2. What is the ratio of the Mineral Rent(as % of GDP) of Oil in 2004 to that in 2008?
Ensure brevity in your answer.  0.59. What is the ratio of the Mineral Rent(as % of GDP) of Other Minerals in 2004 to that in 2008?
Provide a succinct answer. 0.25. What is the ratio of the Mineral Rent(as % of GDP) of Coal in 2004 to that in 2009?
Offer a terse response. 0.09. What is the ratio of the Mineral Rent(as % of GDP) of Natural Gas in 2004 to that in 2009?
Your answer should be compact. 0.46. What is the ratio of the Mineral Rent(as % of GDP) of Oil in 2004 to that in 2009?
Your answer should be compact. 0.95. What is the ratio of the Mineral Rent(as % of GDP) in Other Minerals in 2004 to that in 2009?
Ensure brevity in your answer.  0.32. What is the ratio of the Mineral Rent(as % of GDP) of Coal in 2005 to that in 2006?
Your answer should be compact. 0.26. What is the ratio of the Mineral Rent(as % of GDP) in Natural Gas in 2005 to that in 2006?
Offer a very short reply. 1.04. What is the ratio of the Mineral Rent(as % of GDP) of Oil in 2005 to that in 2006?
Give a very brief answer. 0.92. What is the ratio of the Mineral Rent(as % of GDP) of Other Minerals in 2005 to that in 2006?
Your answer should be compact. 0.36. What is the ratio of the Mineral Rent(as % of GDP) in Coal in 2005 to that in 2007?
Your answer should be very brief. 0.08. What is the ratio of the Mineral Rent(as % of GDP) of Natural Gas in 2005 to that in 2007?
Your response must be concise. 0.81. What is the ratio of the Mineral Rent(as % of GDP) of Other Minerals in 2005 to that in 2007?
Ensure brevity in your answer.  0.34. What is the ratio of the Mineral Rent(as % of GDP) in Coal in 2005 to that in 2008?
Offer a terse response. 0.01. What is the ratio of the Mineral Rent(as % of GDP) of Natural Gas in 2005 to that in 2008?
Keep it short and to the point. 0.51. What is the ratio of the Mineral Rent(as % of GDP) in Oil in 2005 to that in 2008?
Give a very brief answer. 0.82. What is the ratio of the Mineral Rent(as % of GDP) in Other Minerals in 2005 to that in 2008?
Your response must be concise. 0.43. What is the ratio of the Mineral Rent(as % of GDP) in Coal in 2005 to that in 2009?
Your answer should be compact. 0.03. What is the ratio of the Mineral Rent(as % of GDP) of Natural Gas in 2005 to that in 2009?
Offer a very short reply. 1.16. What is the ratio of the Mineral Rent(as % of GDP) in Oil in 2005 to that in 2009?
Provide a succinct answer. 1.33. What is the ratio of the Mineral Rent(as % of GDP) of Other Minerals in 2005 to that in 2009?
Provide a short and direct response. 0.56. What is the ratio of the Mineral Rent(as % of GDP) of Coal in 2006 to that in 2007?
Keep it short and to the point. 0.3. What is the ratio of the Mineral Rent(as % of GDP) in Natural Gas in 2006 to that in 2007?
Your answer should be compact. 0.78. What is the ratio of the Mineral Rent(as % of GDP) of Oil in 2006 to that in 2007?
Your answer should be compact. 1.06. What is the ratio of the Mineral Rent(as % of GDP) of Other Minerals in 2006 to that in 2007?
Offer a very short reply. 0.93. What is the ratio of the Mineral Rent(as % of GDP) of Coal in 2006 to that in 2008?
Provide a succinct answer. 0.06. What is the ratio of the Mineral Rent(as % of GDP) in Natural Gas in 2006 to that in 2008?
Offer a terse response. 0.49. What is the ratio of the Mineral Rent(as % of GDP) in Oil in 2006 to that in 2008?
Keep it short and to the point. 0.89. What is the ratio of the Mineral Rent(as % of GDP) in Other Minerals in 2006 to that in 2008?
Offer a terse response. 1.19. What is the ratio of the Mineral Rent(as % of GDP) in Coal in 2006 to that in 2009?
Ensure brevity in your answer.  0.12. What is the ratio of the Mineral Rent(as % of GDP) of Natural Gas in 2006 to that in 2009?
Your response must be concise. 1.12. What is the ratio of the Mineral Rent(as % of GDP) of Oil in 2006 to that in 2009?
Keep it short and to the point. 1.45. What is the ratio of the Mineral Rent(as % of GDP) in Other Minerals in 2006 to that in 2009?
Your response must be concise. 1.54. What is the ratio of the Mineral Rent(as % of GDP) in Coal in 2007 to that in 2008?
Your response must be concise. 0.19. What is the ratio of the Mineral Rent(as % of GDP) of Natural Gas in 2007 to that in 2008?
Provide a succinct answer. 0.63. What is the ratio of the Mineral Rent(as % of GDP) of Oil in 2007 to that in 2008?
Your answer should be very brief. 0.84. What is the ratio of the Mineral Rent(as % of GDP) in Other Minerals in 2007 to that in 2008?
Your answer should be very brief. 1.29. What is the ratio of the Mineral Rent(as % of GDP) in Coal in 2007 to that in 2009?
Offer a terse response. 0.39. What is the ratio of the Mineral Rent(as % of GDP) of Natural Gas in 2007 to that in 2009?
Offer a terse response. 1.44. What is the ratio of the Mineral Rent(as % of GDP) in Oil in 2007 to that in 2009?
Provide a succinct answer. 1.36. What is the ratio of the Mineral Rent(as % of GDP) of Other Minerals in 2007 to that in 2009?
Provide a short and direct response. 1.66. What is the ratio of the Mineral Rent(as % of GDP) in Coal in 2008 to that in 2009?
Offer a very short reply. 2.03. What is the ratio of the Mineral Rent(as % of GDP) of Natural Gas in 2008 to that in 2009?
Make the answer very short. 2.27. What is the ratio of the Mineral Rent(as % of GDP) of Oil in 2008 to that in 2009?
Make the answer very short. 1.62. What is the ratio of the Mineral Rent(as % of GDP) of Other Minerals in 2008 to that in 2009?
Your answer should be compact. 1.29. What is the difference between the highest and the second highest Mineral Rent(as % of GDP) of Coal?
Ensure brevity in your answer.  0. What is the difference between the highest and the second highest Mineral Rent(as % of GDP) in Natural Gas?
Keep it short and to the point. 0.32. What is the difference between the highest and the second highest Mineral Rent(as % of GDP) in Oil?
Offer a terse response. 0.27. What is the difference between the highest and the second highest Mineral Rent(as % of GDP) of Other Minerals?
Provide a short and direct response. 0.86. What is the difference between the highest and the lowest Mineral Rent(as % of GDP) in Coal?
Keep it short and to the point. 0.01. What is the difference between the highest and the lowest Mineral Rent(as % of GDP) of Natural Gas?
Offer a terse response. 0.7. What is the difference between the highest and the lowest Mineral Rent(as % of GDP) of Oil?
Offer a very short reply. 1.04. What is the difference between the highest and the lowest Mineral Rent(as % of GDP) of Other Minerals?
Offer a very short reply. 9.41. 